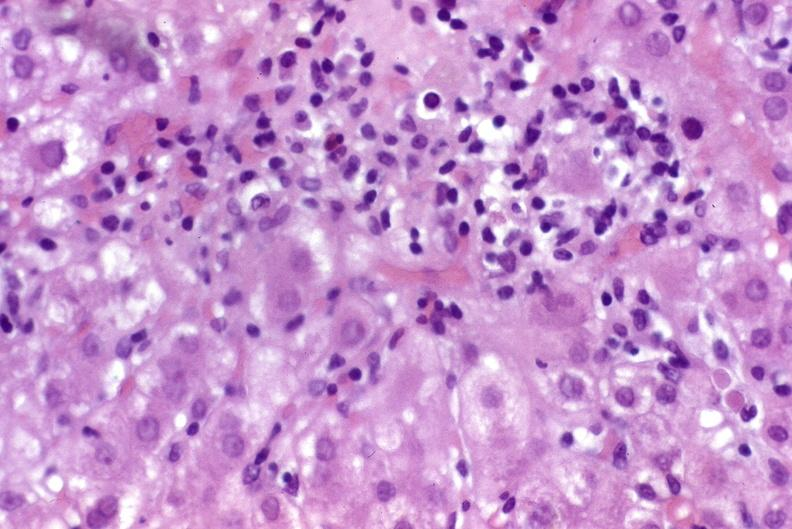s infarct present?
Answer the question using a single word or phrase. No 